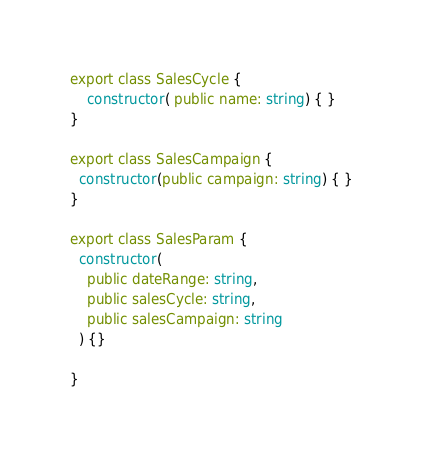Convert code to text. <code><loc_0><loc_0><loc_500><loc_500><_TypeScript_>export class SalesCycle {
    constructor( public name: string) { }
}

export class SalesCampaign {
  constructor(public campaign: string) { }
}

export class SalesParam {
  constructor(
    public dateRange: string,
    public salesCycle: string,
    public salesCampaign: string
  ) {}

}
</code> 